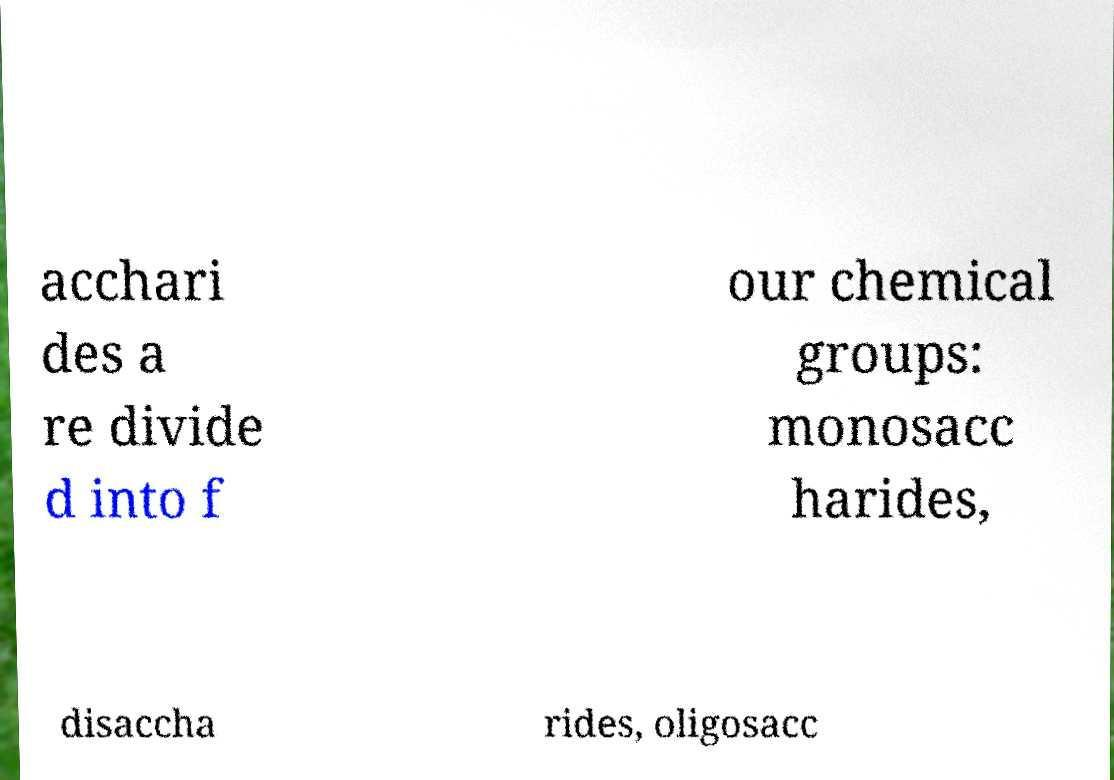Could you assist in decoding the text presented in this image and type it out clearly? acchari des a re divide d into f our chemical groups: monosacc harides, disaccha rides, oligosacc 